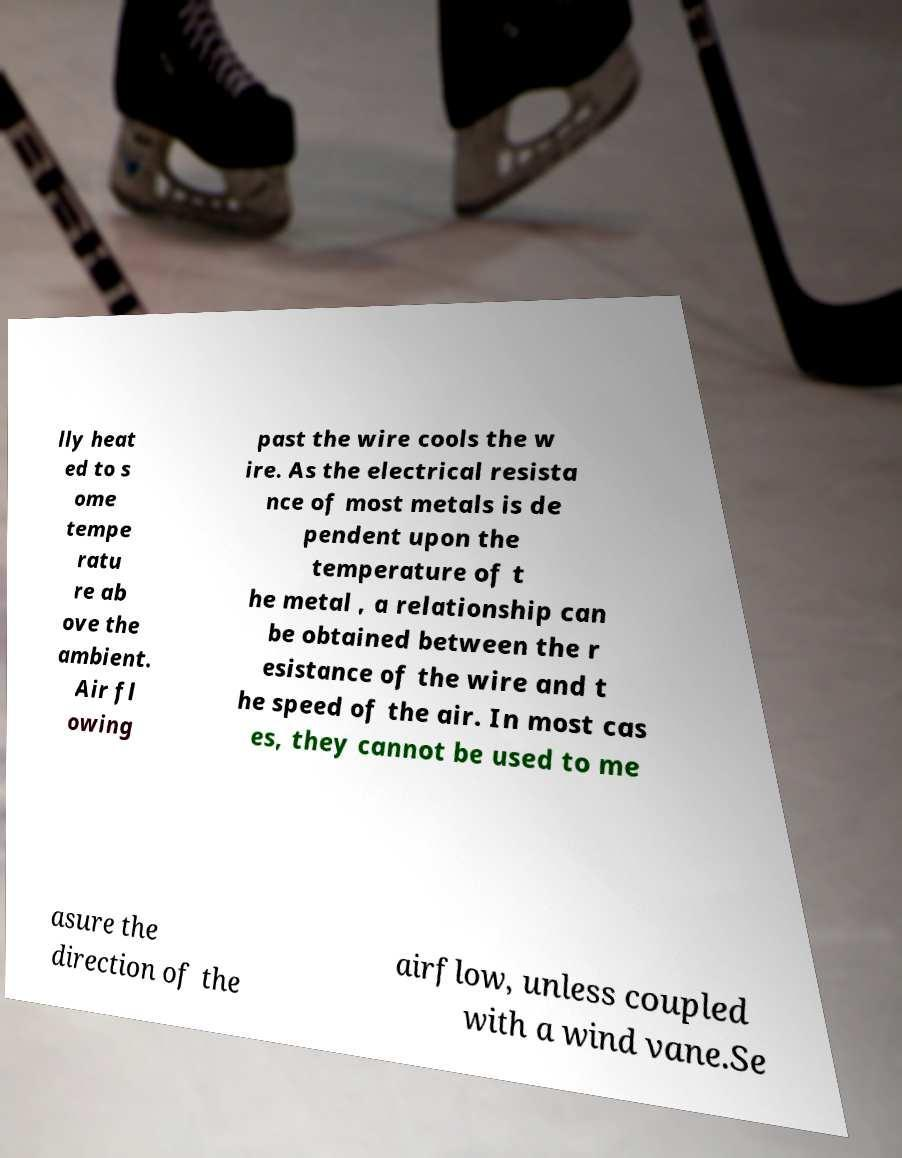Can you accurately transcribe the text from the provided image for me? lly heat ed to s ome tempe ratu re ab ove the ambient. Air fl owing past the wire cools the w ire. As the electrical resista nce of most metals is de pendent upon the temperature of t he metal , a relationship can be obtained between the r esistance of the wire and t he speed of the air. In most cas es, they cannot be used to me asure the direction of the airflow, unless coupled with a wind vane.Se 